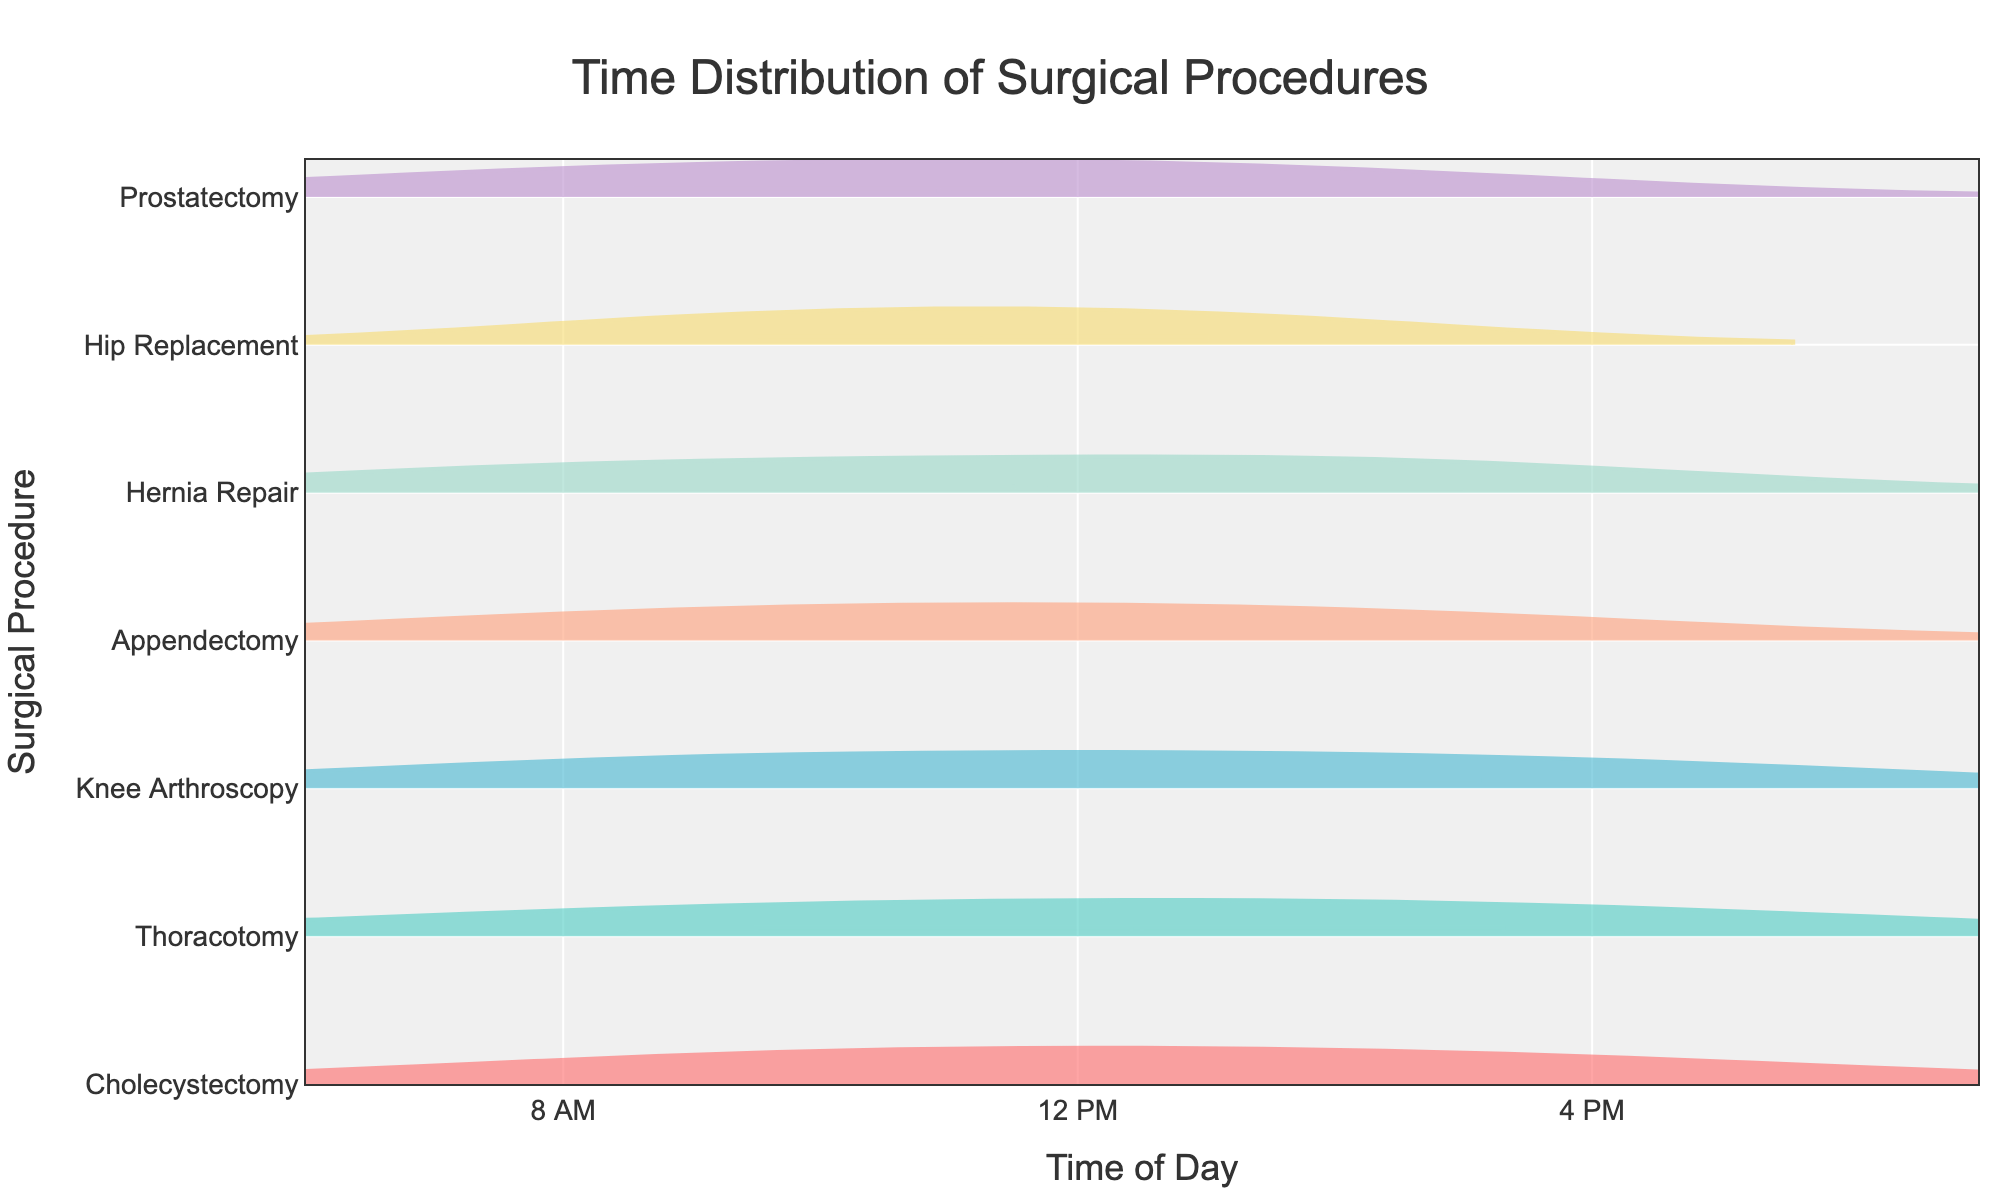what is the title of the chart? The title is located at the top of the chart and provides an overall description of the data presented. It reads, "Time Distribution of Surgical Procedures."
Answer: Time Distribution of Surgical Procedures what does the x-axis represent? The x-axis label at the bottom of the chart indicates that it represents the "Time of Day," with tick values marking time intervals from 6 AM to 7 PM.
Answer: Time of Day which procedure has the earliest average start time? The y-axis lists surgical procedures sorted by average start time. The procedure at the bottom has the earliest average start time.
Answer: Hernia Repair which surgical procedure has the widest spread of start times? The width of the violin plot along the x-axis indicates the spread of start times. The procedure with the widest horizontal distribution has the widest spread.
Answer: Prostatectomy at what time does the first "Appendectomy" start? Check the horizontal position of the leftmost data point in the Appendectomy violin plot. It starts at approximately 08:15.
Answer: 08:15 what is the duration of "Hip Replacement" procedures? The procedure durations are reflected in the spread along the x-axis within each violin plot. Hip Replacement durations range approximately from 180 to 360 minutes.
Answer: 180 to 360 minutes compare the average start times of "Thoracotomy" and "Knee Arthroscopy" Observe the central lines within the violin plots. Thoracotomy starts on average around 11:30 AM, while Knee Arthroscopy starts near 10:00 AM.
Answer: Knee Arthroscopy starts earlier how often do procedures end by 2 PM? Identifying density within the violin plots before the 840-minute mark (2 PM). Procedures such as Hernia Repair, Appendectomy, and part of Knee Arthroscopy commonly end before 2 PM.
Answer: Several which procedures show a positive skew in start times? A positive skew is shown as a concentration towards earlier times in the violin plot, with a long tail extending to later times. Procedures like Appendectomy and Prostatectomy exhibit positive skew.
Answer: Appendectomy, Prostatectomy 